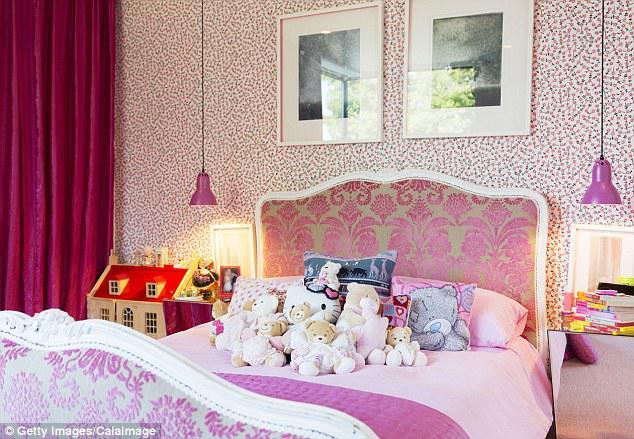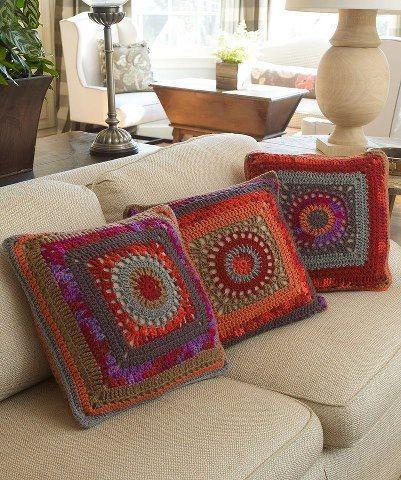The first image is the image on the left, the second image is the image on the right. Assess this claim about the two images: "A pale neutral-colored sofa is topped with a row of at least three colorful square throw pillows in one image.". Correct or not? Answer yes or no. Yes. The first image is the image on the left, the second image is the image on the right. Evaluate the accuracy of this statement regarding the images: "There are stuffed animals on a bed.". Is it true? Answer yes or no. Yes. 